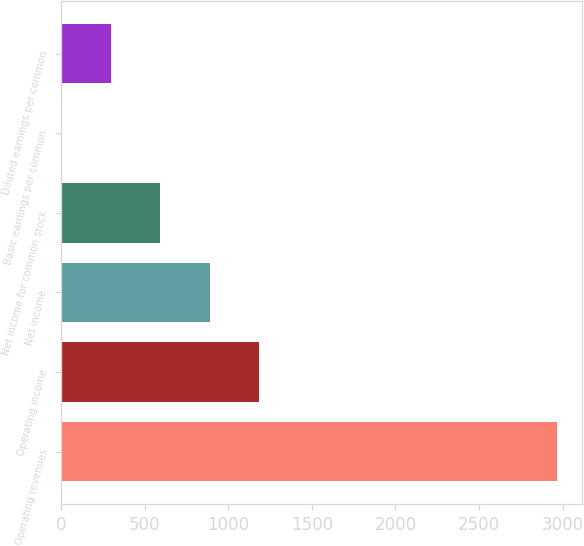<chart> <loc_0><loc_0><loc_500><loc_500><bar_chart><fcel>Operating revenues<fcel>Operating income<fcel>Net income<fcel>Net income for common stock<fcel>Basic earnings per common<fcel>Diluted earnings per common<nl><fcel>2967<fcel>1187.17<fcel>890.54<fcel>593.91<fcel>0.65<fcel>297.28<nl></chart> 